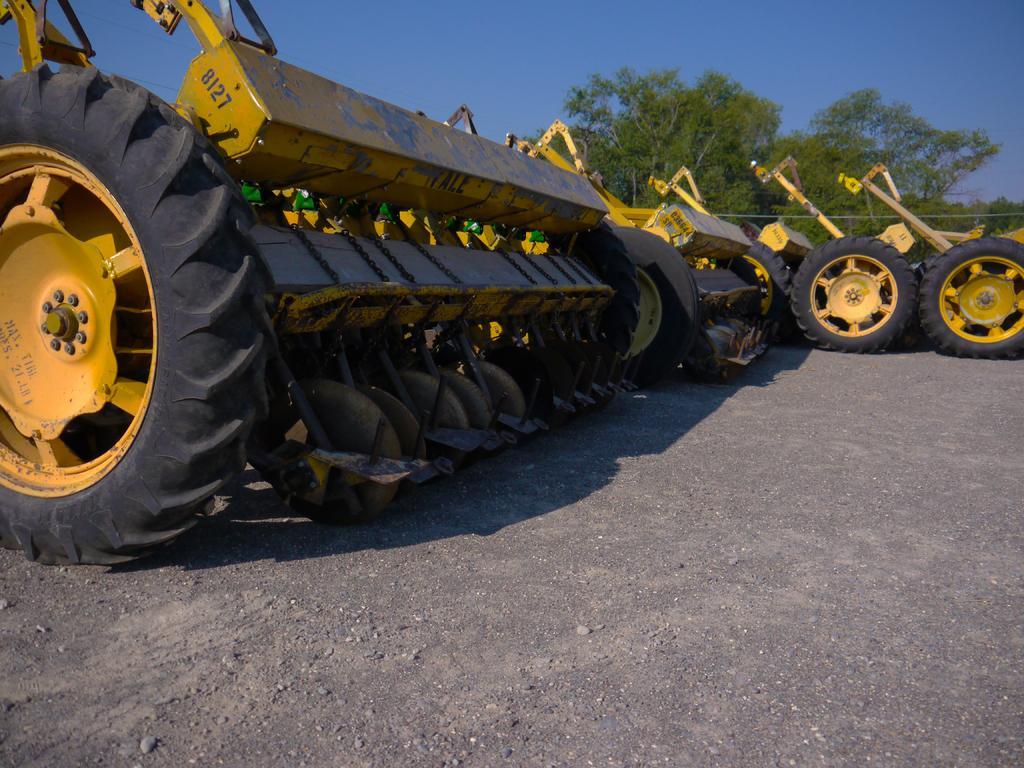Could you give a brief overview of what you see in this image? In the image in the center, we can see few tractors, which are in yellow color. In the background we can see the sky and trees. 